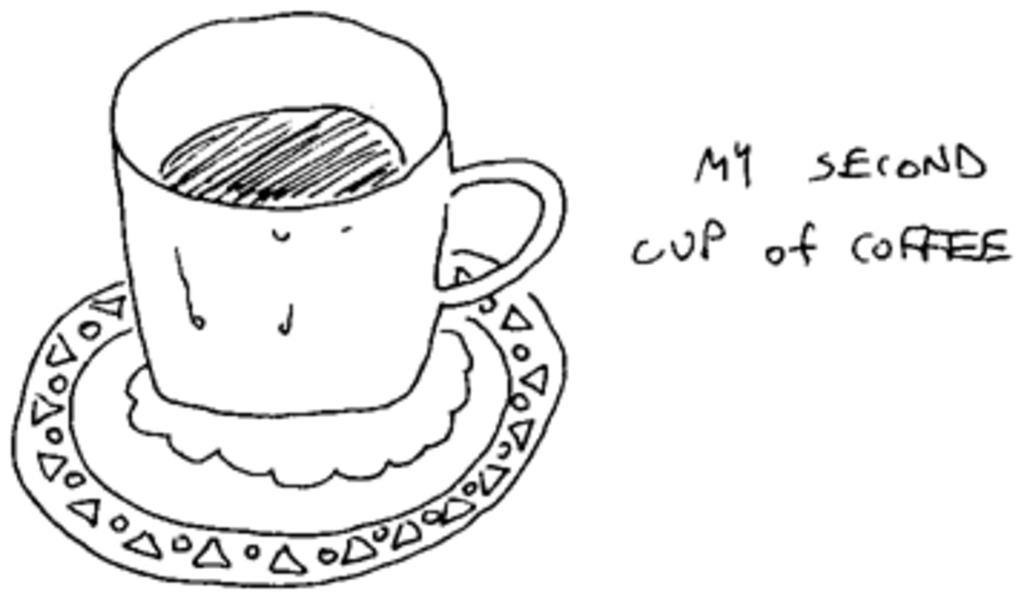What is depicted in the drawing on the left side of the image? There is a drawing of a cup in the image. What is depicted in the drawing on the right side of the image? There is a drawing of a saucer in the image. What can be found on the right side of the image besides the drawing of the saucer? There is text or writing on the right side of the image. How many visitors are present in the image? There are no visitors present in the image; it contains only drawings of a cup and a saucer, along with text or writing. 